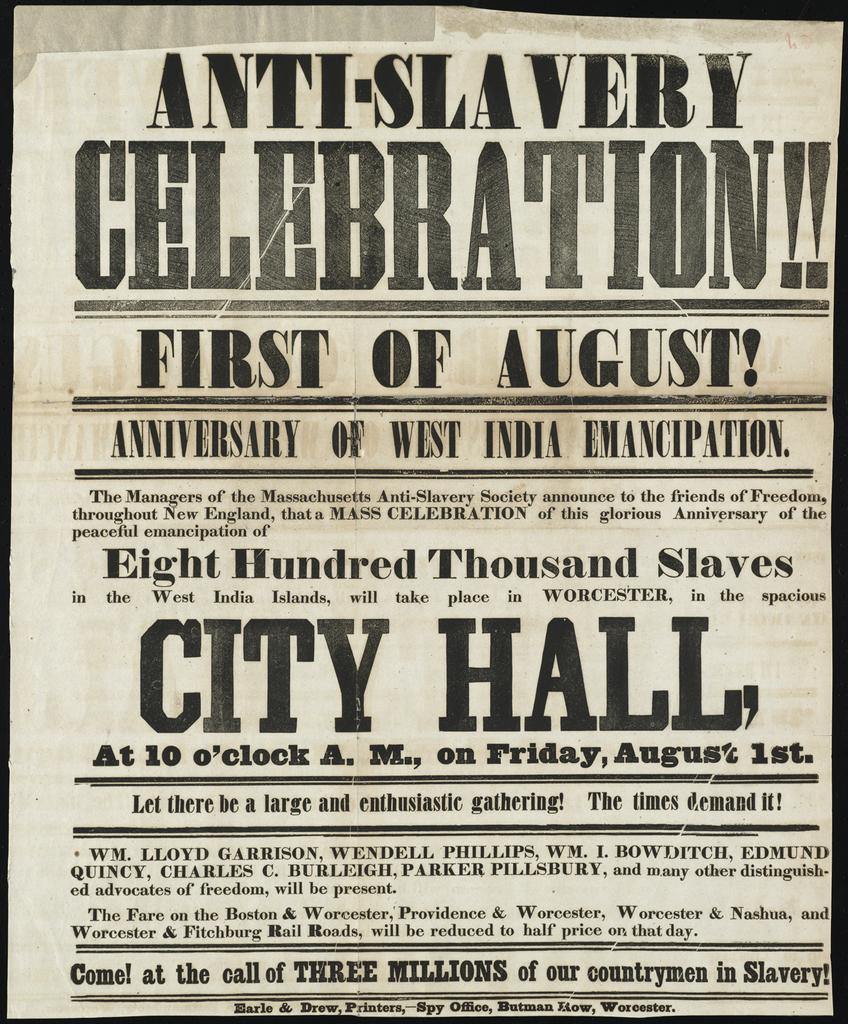Provide a one-sentence caption for the provided image. An newspaper advertising an anti-slavery celebration for the first of August. 